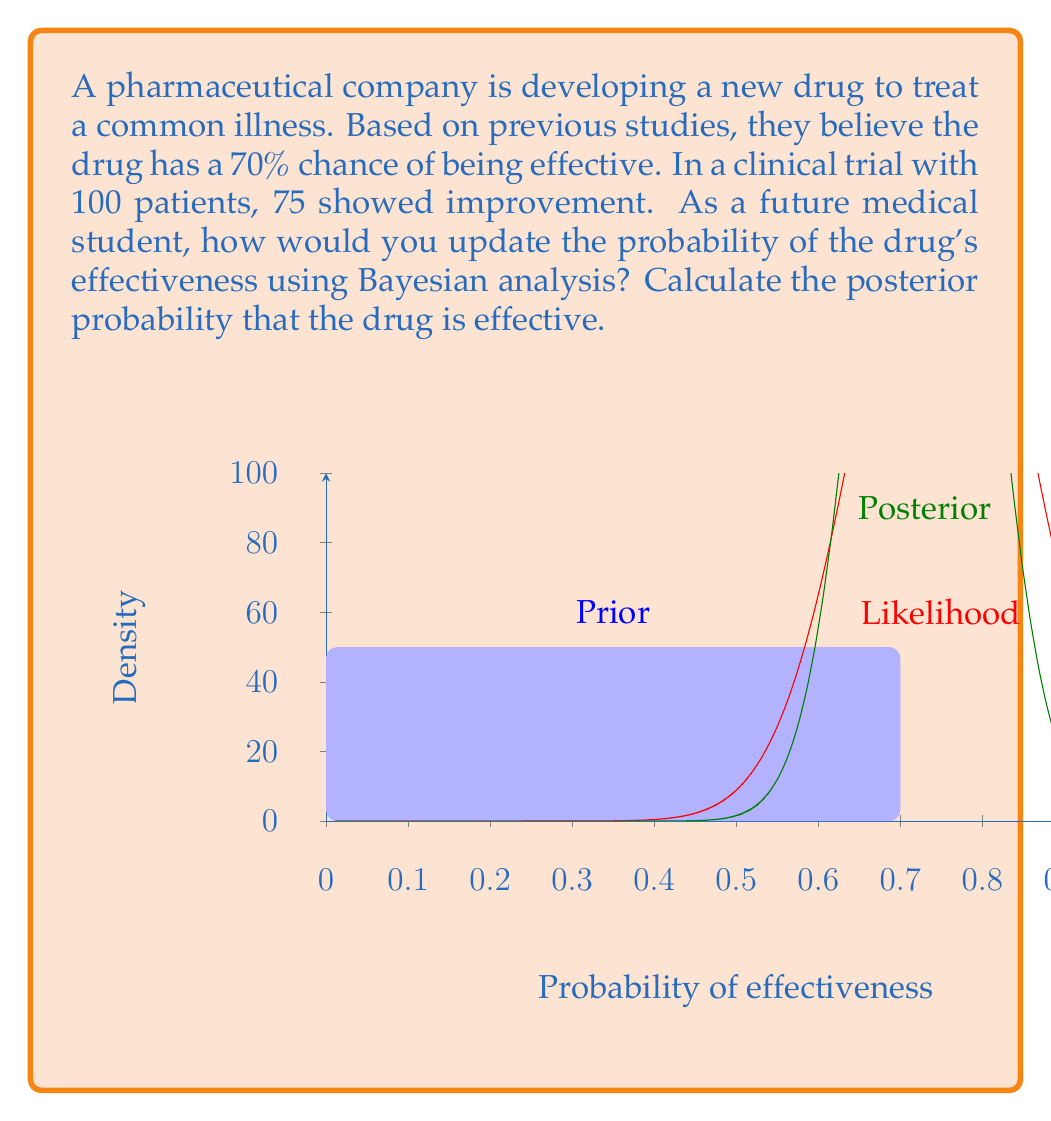Show me your answer to this math problem. To solve this problem using Bayesian analysis, we'll follow these steps:

1) Define our prior probability:
   $P(E) = 0.7$ (probability that the drug is effective based on previous studies)

2) Calculate the likelihood of our observed data given the drug is effective:
   $P(D|E) = \binom{100}{75} \cdot 0.7^{75} \cdot 0.3^{25}$

3) Calculate the likelihood of our observed data given the drug is not effective:
   $P(D|N) = \binom{100}{75} \cdot 0.3^{75} \cdot 0.7^{25}$

4) Apply Bayes' theorem:
   $$P(E|D) = \frac{P(D|E) \cdot P(E)}{P(D|E) \cdot P(E) + P(D|N) \cdot P(N)}$$

   Where $P(N) = 1 - P(E) = 0.3$

5) Substitute the values:
   $$P(E|D) = \frac{(\binom{100}{75} \cdot 0.7^{75} \cdot 0.3^{25}) \cdot 0.7}{(\binom{100}{75} \cdot 0.7^{75} \cdot 0.3^{25}) \cdot 0.7 + (\binom{100}{75} \cdot 0.3^{75} \cdot 0.7^{25}) \cdot 0.3}$$

6) Calculate:
   $$P(E|D) \approx 0.9892$$

The posterior probability that the drug is effective, given the clinical trial data, is approximately 0.9892 or 98.92%.
Answer: $P(E|D) \approx 0.9892$ 